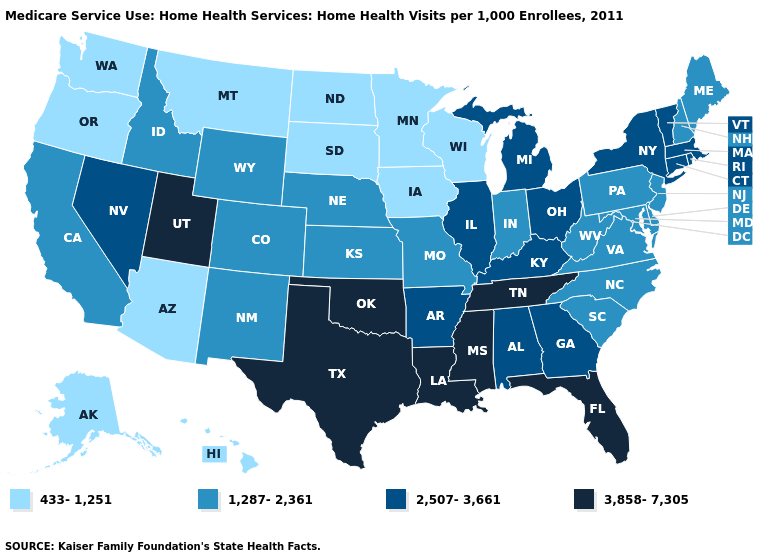Does Massachusetts have the highest value in the USA?
Concise answer only. No. Does New Jersey have the highest value in the Northeast?
Keep it brief. No. What is the value of Indiana?
Keep it brief. 1,287-2,361. What is the lowest value in the USA?
Be succinct. 433-1,251. What is the value of Wyoming?
Short answer required. 1,287-2,361. Is the legend a continuous bar?
Quick response, please. No. What is the lowest value in the USA?
Concise answer only. 433-1,251. Does Ohio have a lower value than Alaska?
Keep it brief. No. What is the value of Oklahoma?
Quick response, please. 3,858-7,305. Which states have the lowest value in the South?
Concise answer only. Delaware, Maryland, North Carolina, South Carolina, Virginia, West Virginia. How many symbols are there in the legend?
Quick response, please. 4. Name the states that have a value in the range 433-1,251?
Quick response, please. Alaska, Arizona, Hawaii, Iowa, Minnesota, Montana, North Dakota, Oregon, South Dakota, Washington, Wisconsin. Does Kansas have the highest value in the MidWest?
Answer briefly. No. Is the legend a continuous bar?
Give a very brief answer. No. What is the value of Maine?
Answer briefly. 1,287-2,361. 